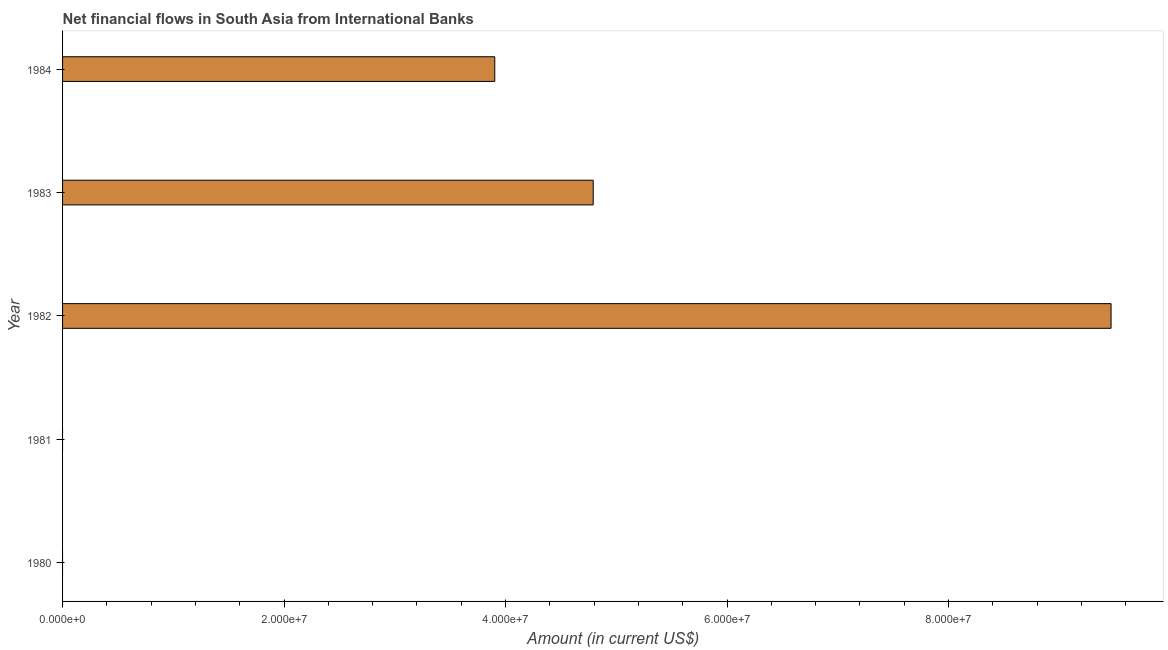Does the graph contain grids?
Give a very brief answer. No. What is the title of the graph?
Provide a short and direct response. Net financial flows in South Asia from International Banks. What is the label or title of the X-axis?
Your answer should be compact. Amount (in current US$). What is the label or title of the Y-axis?
Keep it short and to the point. Year. What is the net financial flows from ibrd in 1981?
Offer a very short reply. 0. Across all years, what is the maximum net financial flows from ibrd?
Make the answer very short. 9.47e+07. Across all years, what is the minimum net financial flows from ibrd?
Give a very brief answer. 0. In which year was the net financial flows from ibrd maximum?
Your answer should be very brief. 1982. What is the sum of the net financial flows from ibrd?
Provide a short and direct response. 1.82e+08. What is the difference between the net financial flows from ibrd in 1982 and 1983?
Provide a succinct answer. 4.68e+07. What is the average net financial flows from ibrd per year?
Provide a succinct answer. 3.63e+07. What is the median net financial flows from ibrd?
Ensure brevity in your answer.  3.90e+07. In how many years, is the net financial flows from ibrd greater than 24000000 US$?
Your answer should be compact. 3. What is the ratio of the net financial flows from ibrd in 1983 to that in 1984?
Provide a short and direct response. 1.23. Is the difference between the net financial flows from ibrd in 1982 and 1983 greater than the difference between any two years?
Provide a short and direct response. No. What is the difference between the highest and the second highest net financial flows from ibrd?
Give a very brief answer. 4.68e+07. Is the sum of the net financial flows from ibrd in 1982 and 1984 greater than the maximum net financial flows from ibrd across all years?
Keep it short and to the point. Yes. What is the difference between the highest and the lowest net financial flows from ibrd?
Your answer should be very brief. 9.47e+07. What is the difference between two consecutive major ticks on the X-axis?
Your response must be concise. 2.00e+07. Are the values on the major ticks of X-axis written in scientific E-notation?
Make the answer very short. Yes. What is the Amount (in current US$) of 1981?
Make the answer very short. 0. What is the Amount (in current US$) in 1982?
Your response must be concise. 9.47e+07. What is the Amount (in current US$) in 1983?
Offer a very short reply. 4.79e+07. What is the Amount (in current US$) in 1984?
Offer a very short reply. 3.90e+07. What is the difference between the Amount (in current US$) in 1982 and 1983?
Give a very brief answer. 4.68e+07. What is the difference between the Amount (in current US$) in 1982 and 1984?
Make the answer very short. 5.56e+07. What is the difference between the Amount (in current US$) in 1983 and 1984?
Offer a terse response. 8.89e+06. What is the ratio of the Amount (in current US$) in 1982 to that in 1983?
Your response must be concise. 1.98. What is the ratio of the Amount (in current US$) in 1982 to that in 1984?
Give a very brief answer. 2.43. What is the ratio of the Amount (in current US$) in 1983 to that in 1984?
Provide a short and direct response. 1.23. 